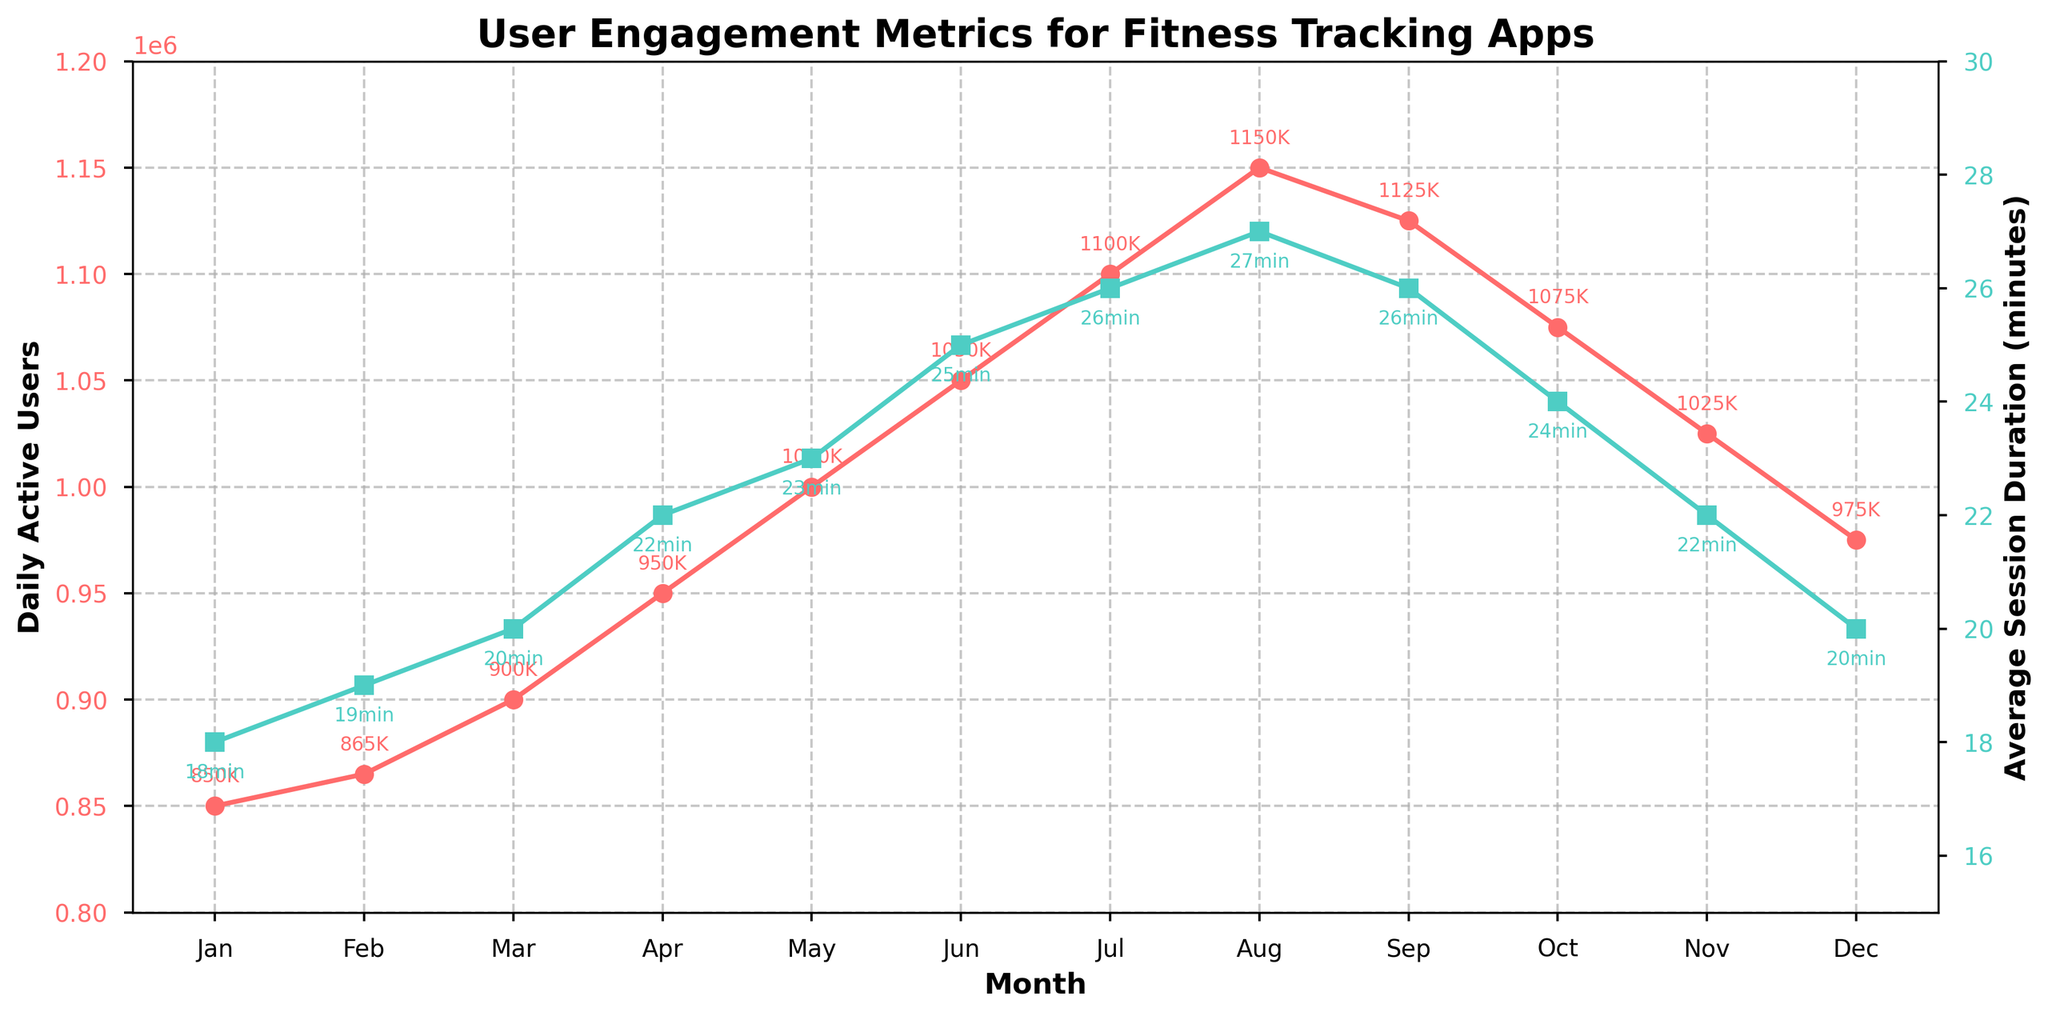What's the month with the highest Daily Active Users? To determine the month with the highest Daily Active Users, observe the red line on the graph. The peak of this line represents the maximum value. From the figure, July shows the highest number, 1,100,000 users.
Answer: July Which month had the longest Average Session Duration, and what was it? To identify the month with the longest Average Session Duration, look at the green line peaks on the graph. August has the highest peak in this line, with a duration of 27 minutes.
Answer: August, 27 minutes Is there a noticeable trend in Daily Active Users from January to December? Observe the red line from January to December. Initially, there's a steady increase, reaching a peak in July, followed by a slight decline towards December. The overall trend shows an increase followed by a decrease.
Answer: Increase then decrease Compare the Average Session Duration in June and September. Which month had a higher value and by how much? Check the green line values for June and September. June has a session duration of 25 minutes, and September has 26 minutes. Subtract to find the difference: 26 - 25 = 1 minute. September is higher by 1 minute.
Answer: September, 1 minute In which month did both Daily Active Users and Average Session Duration reach their highest values simultaneously? Identify the peak values for both the red and green lines and check if they coincide. They do not occur simultaneously, as the highest Daily Active Users are in July and the highest Average Session Duration is in August.
Answer: None By how much did the Daily Active Users increase from April to May? Note the values for April and May on the red line. April had 950,000 users, and May had 1,000,000 users. The difference is 1,000,000 - 950,000 = 50,000 users.
Answer: 50,000 users What was the Average Session Duration in October, and how did it compare to the value in November? Observe the green line's positions for October and November. October had a 24-minute duration, while November had 22 minutes. October’s duration is longer by 2 minutes.
Answer: October was longer by 2 minutes Which month saw the steepest increase in Daily Active Users compared to the preceding month? Observe the monthly increments in the red line. The largest rise is between April and May, from 950,000 to 1,000,000 users, an increase of 50,000 users.
Answer: May Calculate the average Daily Active Users for the first six months of the year. Sum the Daily Active Users from January to June and divide by 6. Total: 850,000 + 865,000 + 900,000 + 950,000 + 1,000,000 + 1,050,000 = 5,615,000. Average: 5,615,000 / 6 ≈ 935,833 users.
Answer: 935,833 users How did the Average Session Duration change from August to December? Examine the green line from August to December. August's duration is 27 minutes, and December's is 20 minutes. The duration decreases by 27 - 20 = 7 minutes.
Answer: Decreased by 7 minutes 